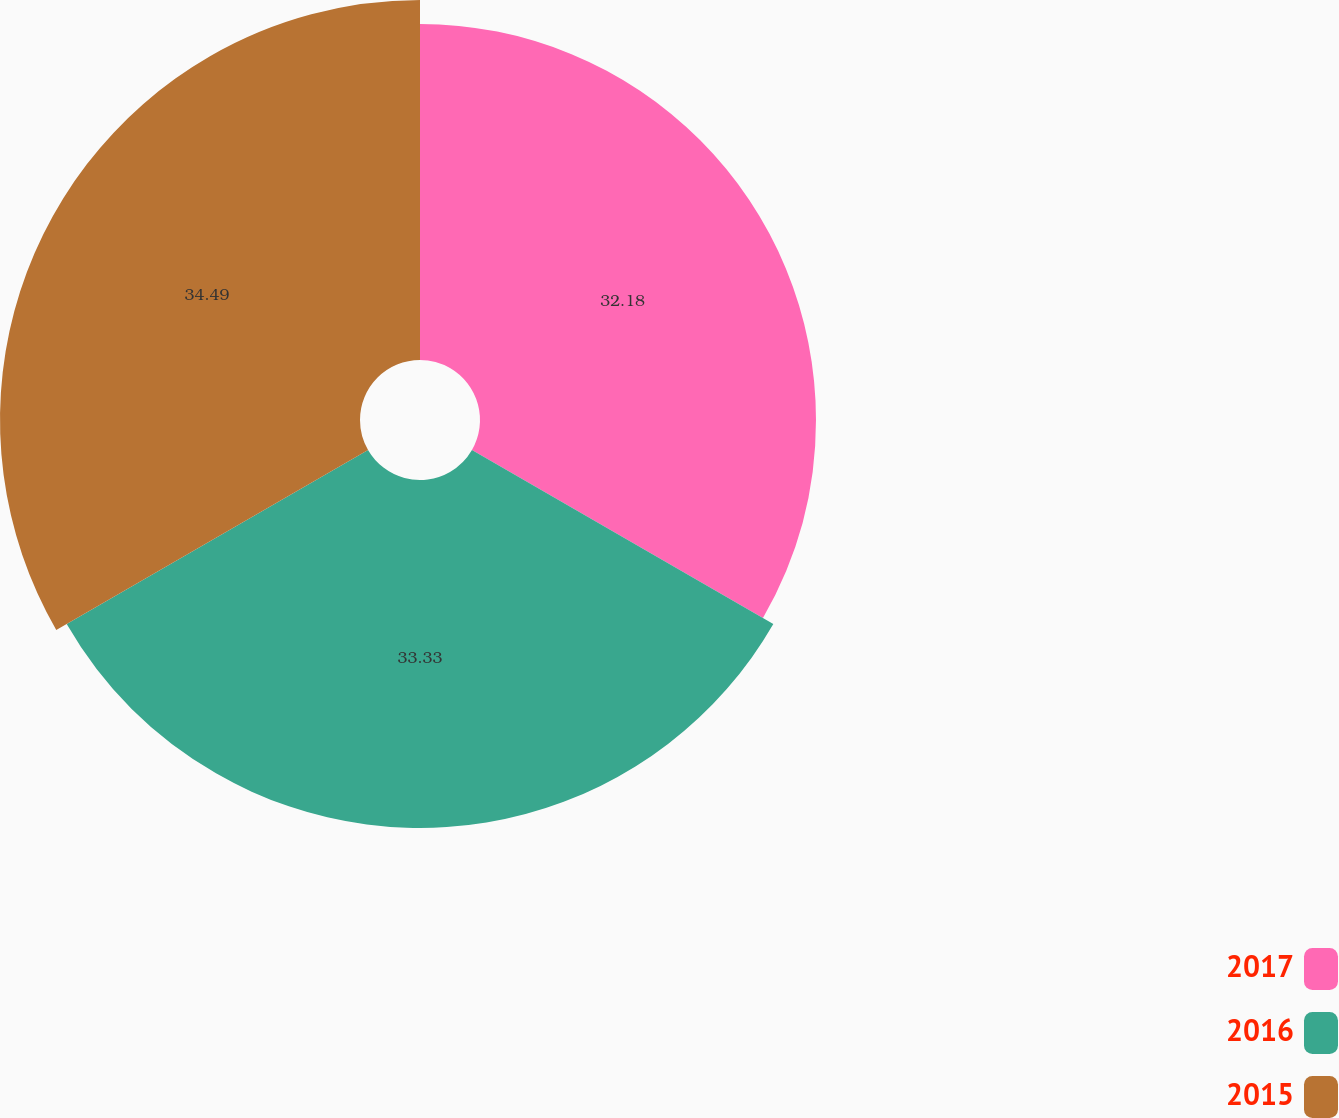Convert chart to OTSL. <chart><loc_0><loc_0><loc_500><loc_500><pie_chart><fcel>2017<fcel>2016<fcel>2015<nl><fcel>32.18%<fcel>33.33%<fcel>34.48%<nl></chart> 